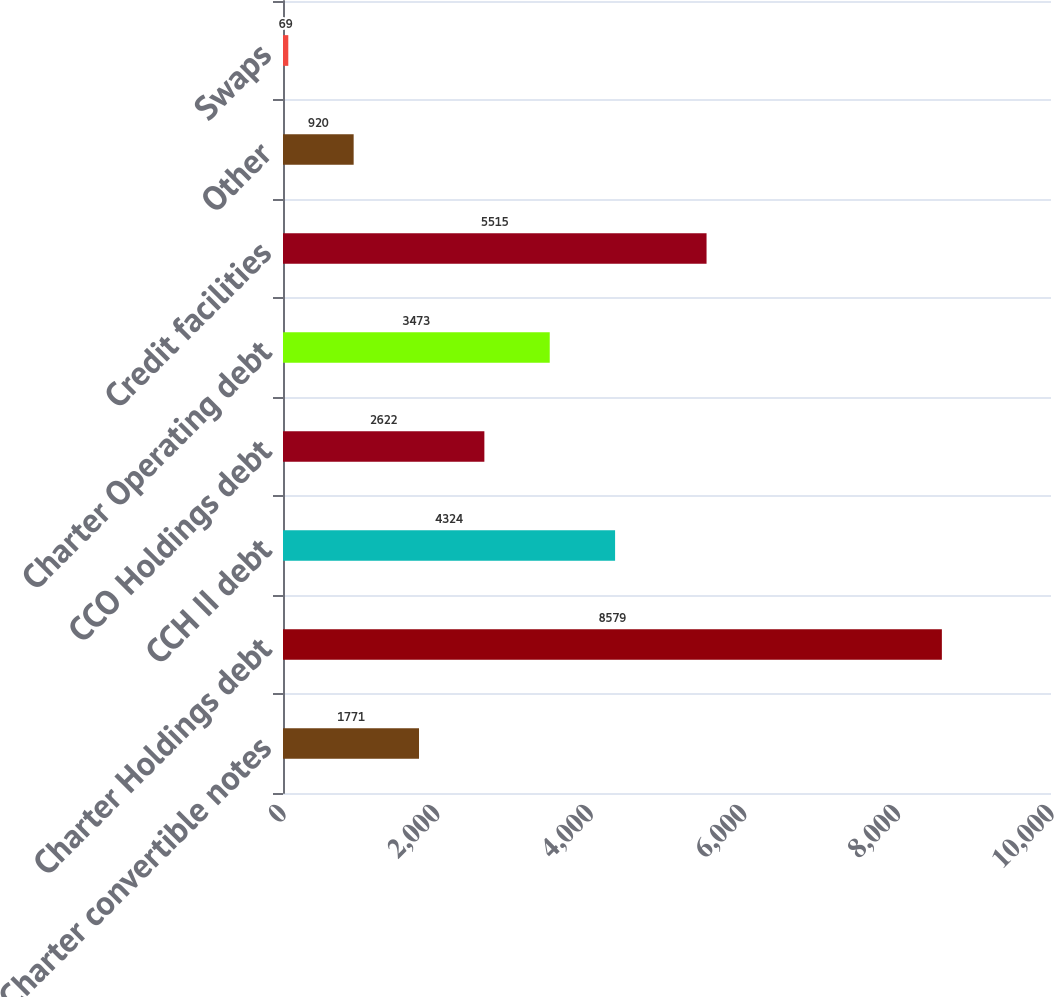<chart> <loc_0><loc_0><loc_500><loc_500><bar_chart><fcel>Charter convertible notes<fcel>Charter Holdings debt<fcel>CCH II debt<fcel>CCO Holdings debt<fcel>Charter Operating debt<fcel>Credit facilities<fcel>Other<fcel>Swaps<nl><fcel>1771<fcel>8579<fcel>4324<fcel>2622<fcel>3473<fcel>5515<fcel>920<fcel>69<nl></chart> 